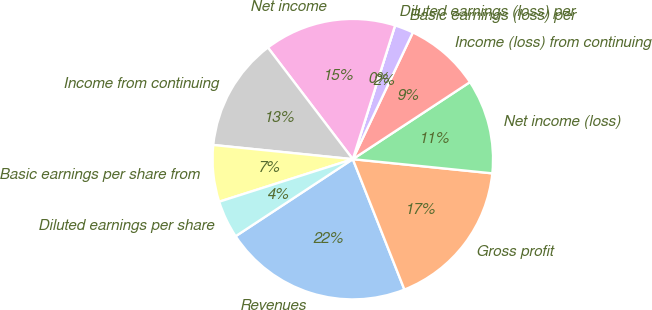<chart> <loc_0><loc_0><loc_500><loc_500><pie_chart><fcel>Revenues<fcel>Gross profit<fcel>Net income (loss)<fcel>Income (loss) from continuing<fcel>Basic earnings (loss) per<fcel>Diluted earnings (loss) per<fcel>Net income<fcel>Income from continuing<fcel>Basic earnings per share from<fcel>Diluted earnings per share<nl><fcel>21.74%<fcel>17.39%<fcel>10.87%<fcel>8.7%<fcel>2.17%<fcel>0.0%<fcel>15.22%<fcel>13.04%<fcel>6.52%<fcel>4.35%<nl></chart> 